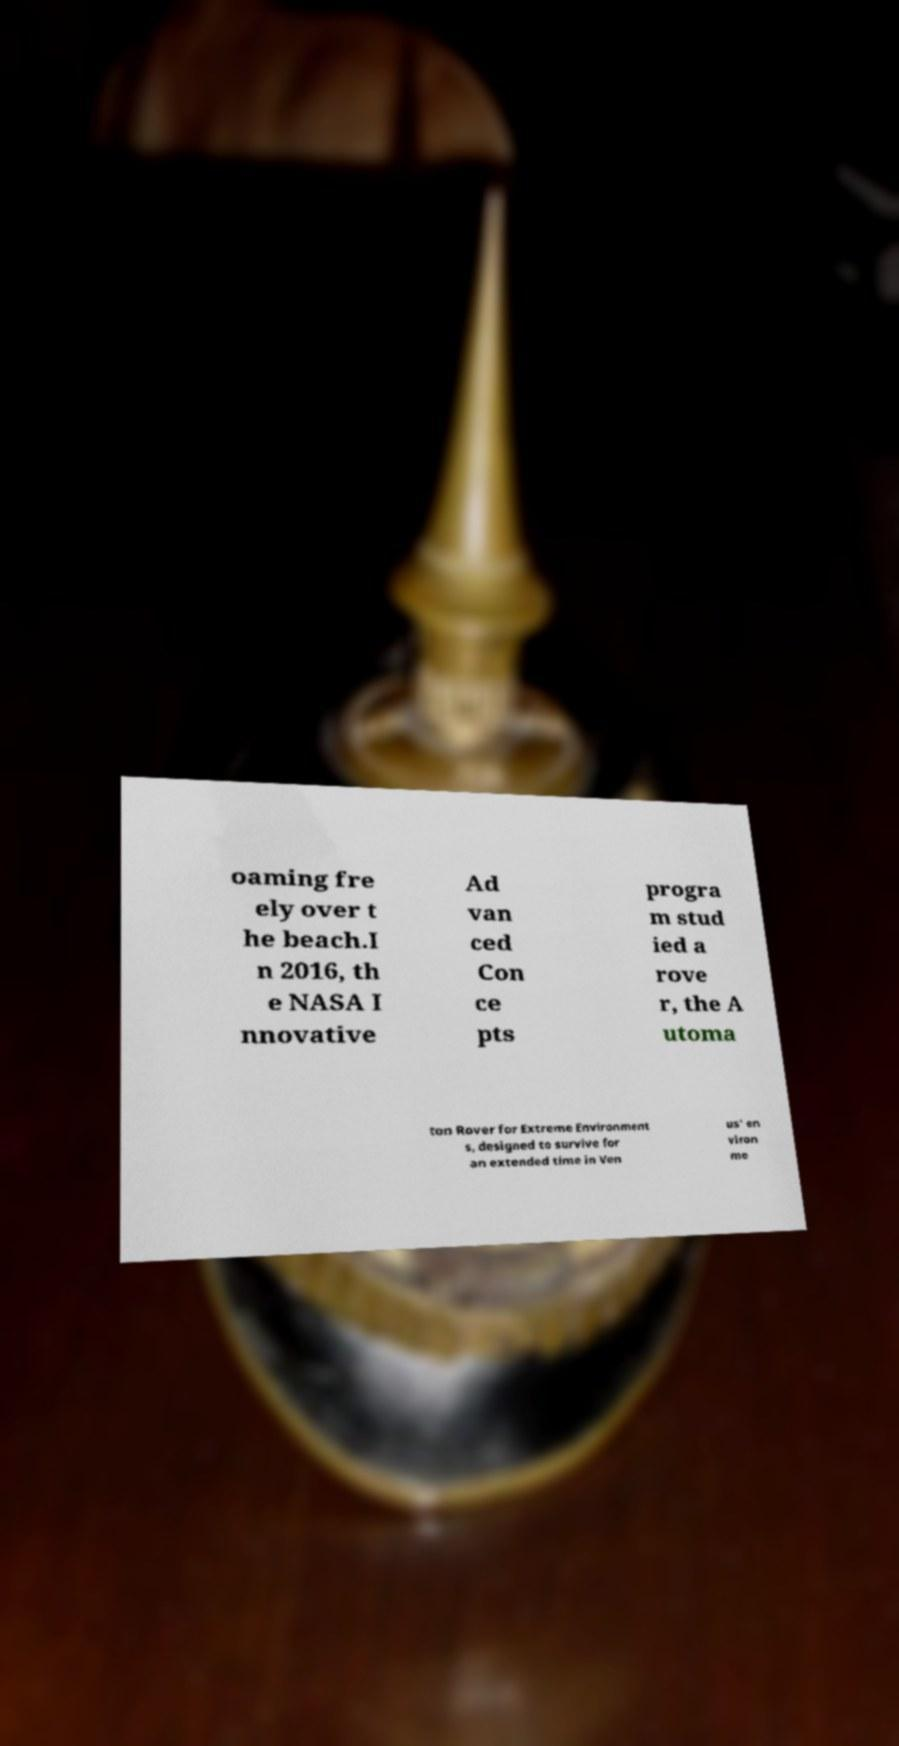Can you accurately transcribe the text from the provided image for me? oaming fre ely over t he beach.I n 2016, th e NASA I nnovative Ad van ced Con ce pts progra m stud ied a rove r, the A utoma ton Rover for Extreme Environment s, designed to survive for an extended time in Ven us' en viron me 